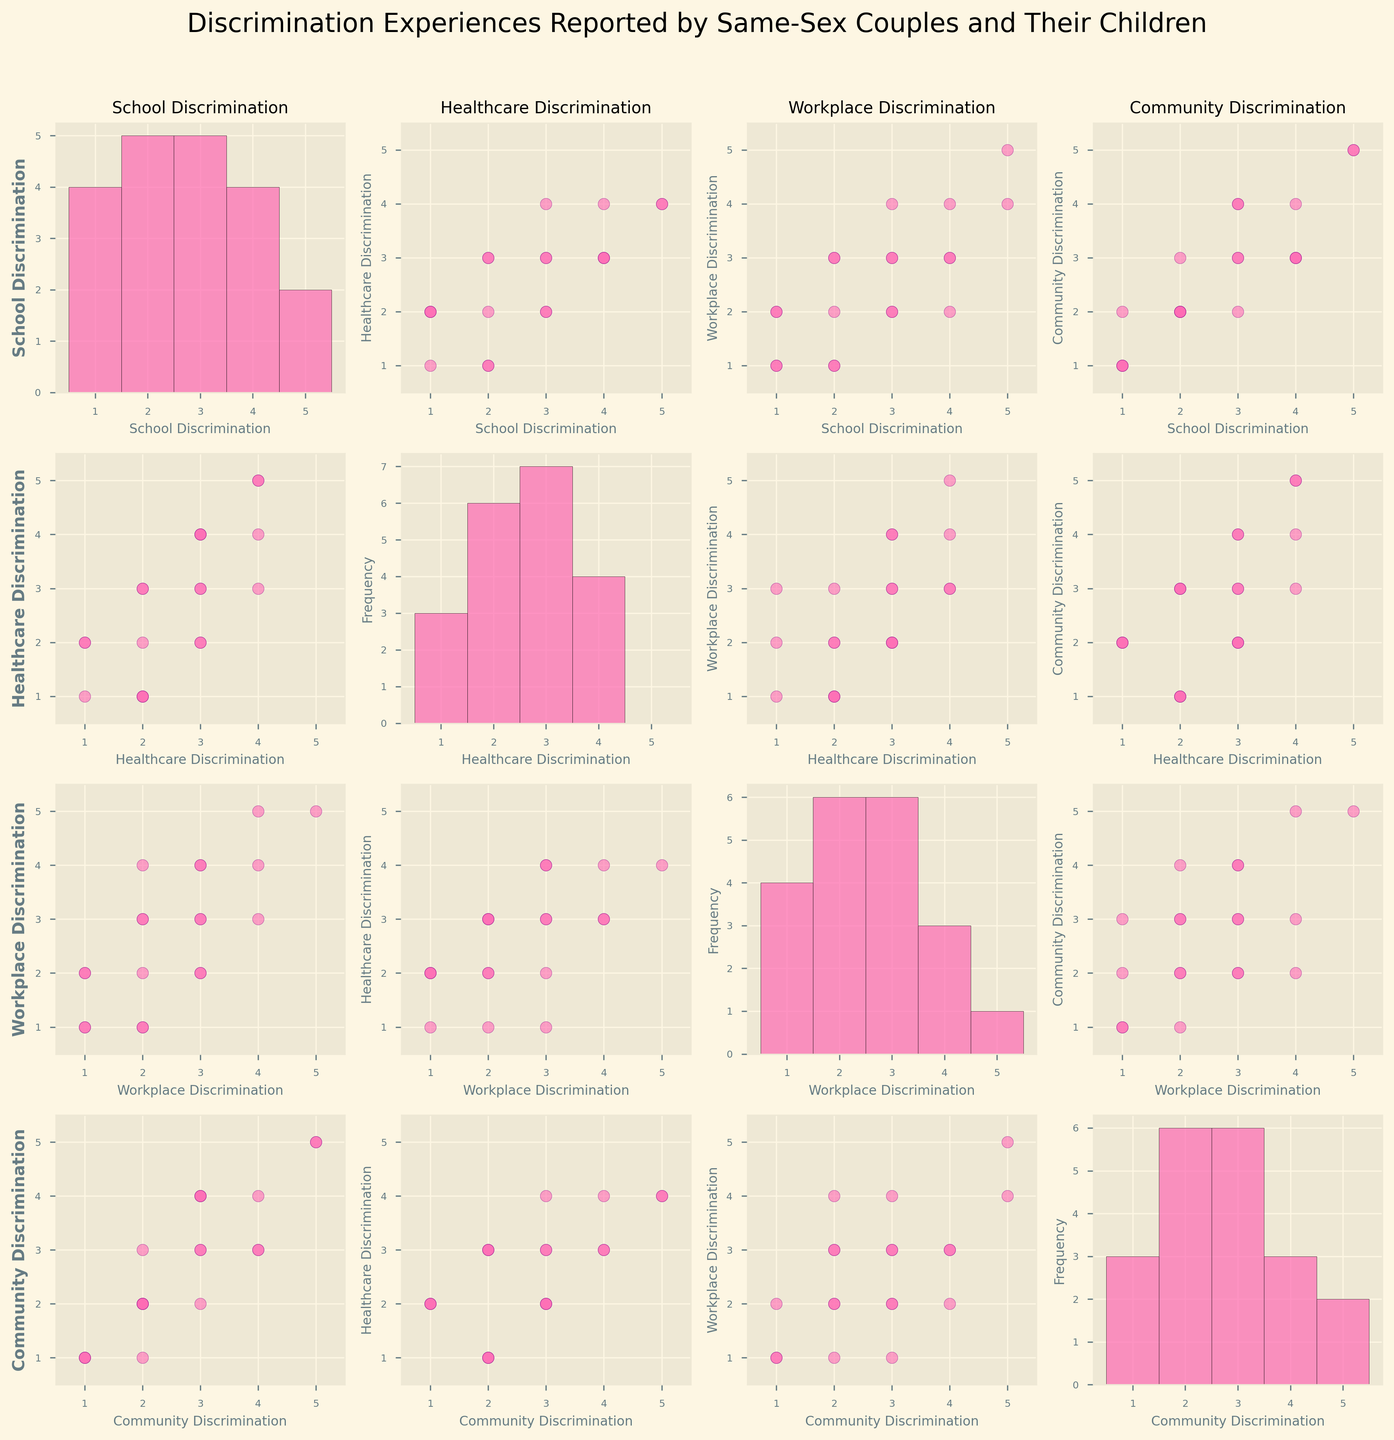What is the title of the figure? The title of the figure is displayed at the top and usually summarizes the main topic or focus. In this case, it is "Discrimination Experiences Reported by Same-Sex Couples and Their Children".
Answer: Discrimination Experiences Reported by Same-Sex Couples and Their Children How many different types of discrimination are analyzed in the figure? There are four types of discrimination analyzed, as indicated by the labels on the axes of the scatterplots and histograms. These are School Discrimination, Healthcare Discrimination, Workplace Discrimination, and Community Discrimination.
Answer: Four Which type of discrimination has the highest frequency in the histogram for School Discrimination? By examining the histogram for School Discrimination (on the diagonal), you can see which score occurs most frequently. The highest frequency is for the score of 2.
Answer: 2 Is there a strong correlation between Healthcare Discrimination and Community Discrimination? To identify a strong correlation, look at how closely the points in the Healthcare Discrimination vs. Community Discrimination scatterplot follow a straight line. The points are somewhat scattered, indicating a moderate correlation.
Answer: Moderate correlation Which discrimination type has the highest individual rating across all families? By looking at the histograms, the highest individual rating across all discrimination types is a 5. This can be observed in the Workplace Discrimination and Community Discrimination histograms.
Answer: 5 Do any families report low (score = 1) discrimination in all four settings? To find families reporting low discrimination in all settings, cross-reference scatterplots and histograms for the score of 1. Families reporting 1 in multiple settings are Smith, Wilson, and Clark.
Answer: Smith, Wilson, Clark If a family reports a high (score = 4 or 5) Work Discrimination experience, what is commonly reported in School Discrimination? Cross-reference the scatterplot of Workplace Discrimination vs. School Discrimination for high Work Discrimination scores (4 or 5). Families with high Work Discrimination scores often report varied School Discrimination scores, commonly 2, 3, or 4.
Answer: 2, 3, or 4 What is the average Workplace Discrimination score reported by the Johnson, Smith, and Lee families? Add the Workplace Discrimination scores for Johnson (3), Smith (1), and Lee (2) and divide by the number of families (3). (3+1+2)/3 equals 2.
Answer: 2 Which two discrimination types appear to have the least correlation based on the scatterplot matrix? Check for scatterplots where the points are most dispersed, indicating little to no correlation. The scatterplot between School Discrimination and Healthcare Discrimination shows the least correlation.
Answer: School Discrimination and Healthcare Discrimination How does the range of reported Community Discrimination scores compare to the range of reported Healthcare Discrimination scores? Compare the spread of scores in the histograms. Both Community and Healthcare Discrimination have a range from 1 to 5, but Community Discrimination often includes higher scores (more frequent 4s and 5s).
Answer: Similar range, Community often higher 